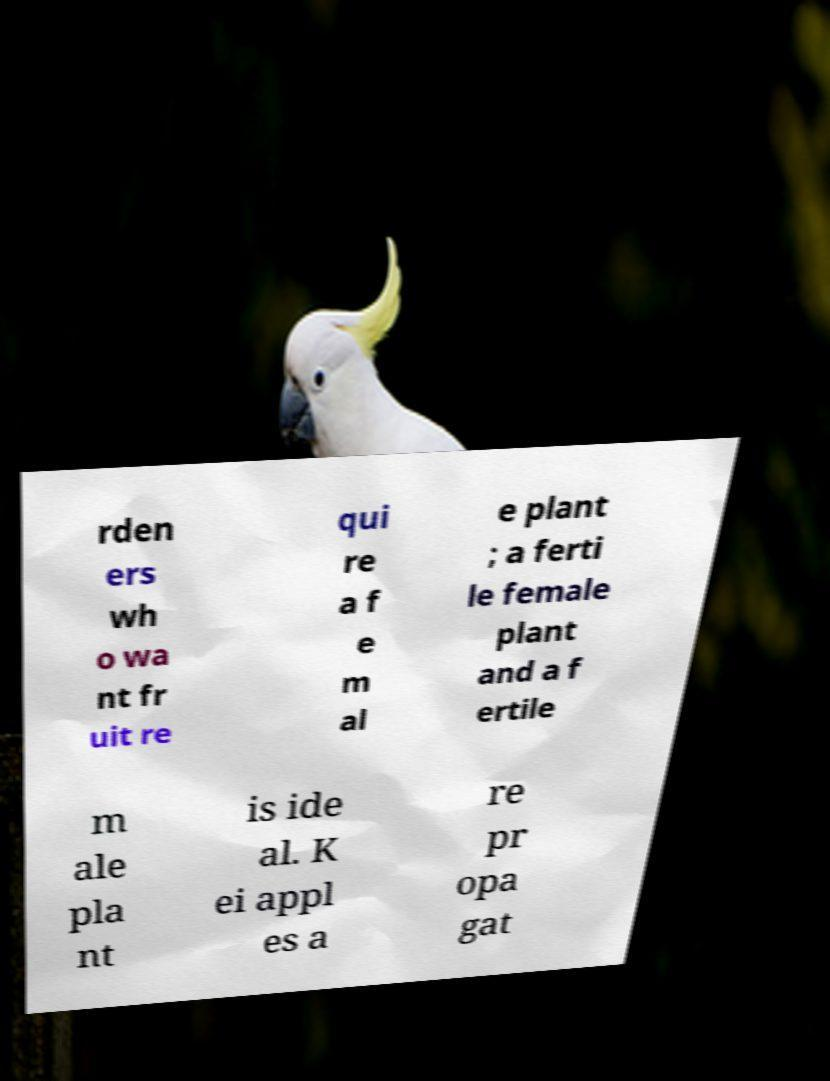What messages or text are displayed in this image? I need them in a readable, typed format. rden ers wh o wa nt fr uit re qui re a f e m al e plant ; a ferti le female plant and a f ertile m ale pla nt is ide al. K ei appl es a re pr opa gat 